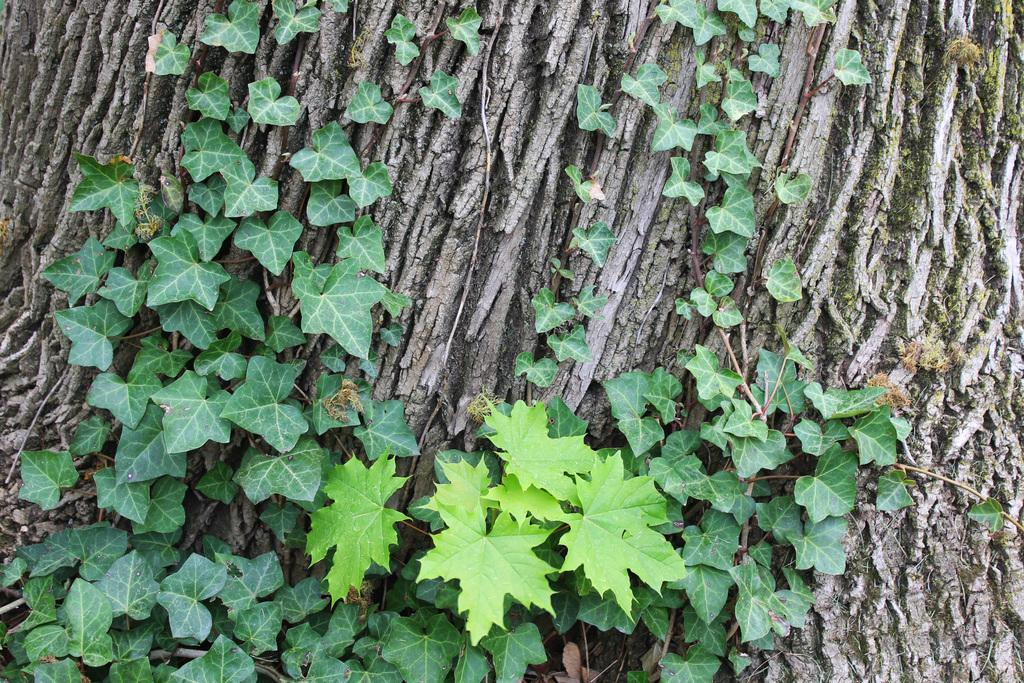What is the main subject of the image? The main subject of the image is a creeper plant. Can you describe the location of the creeper plant in the image? The creeper plant is in the center of the image. What type of straw is the dad using to sip his drink in the image? There is no dad or drink present in the image; it only features a creeper plant. 